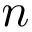<formula> <loc_0><loc_0><loc_500><loc_500>n</formula> 